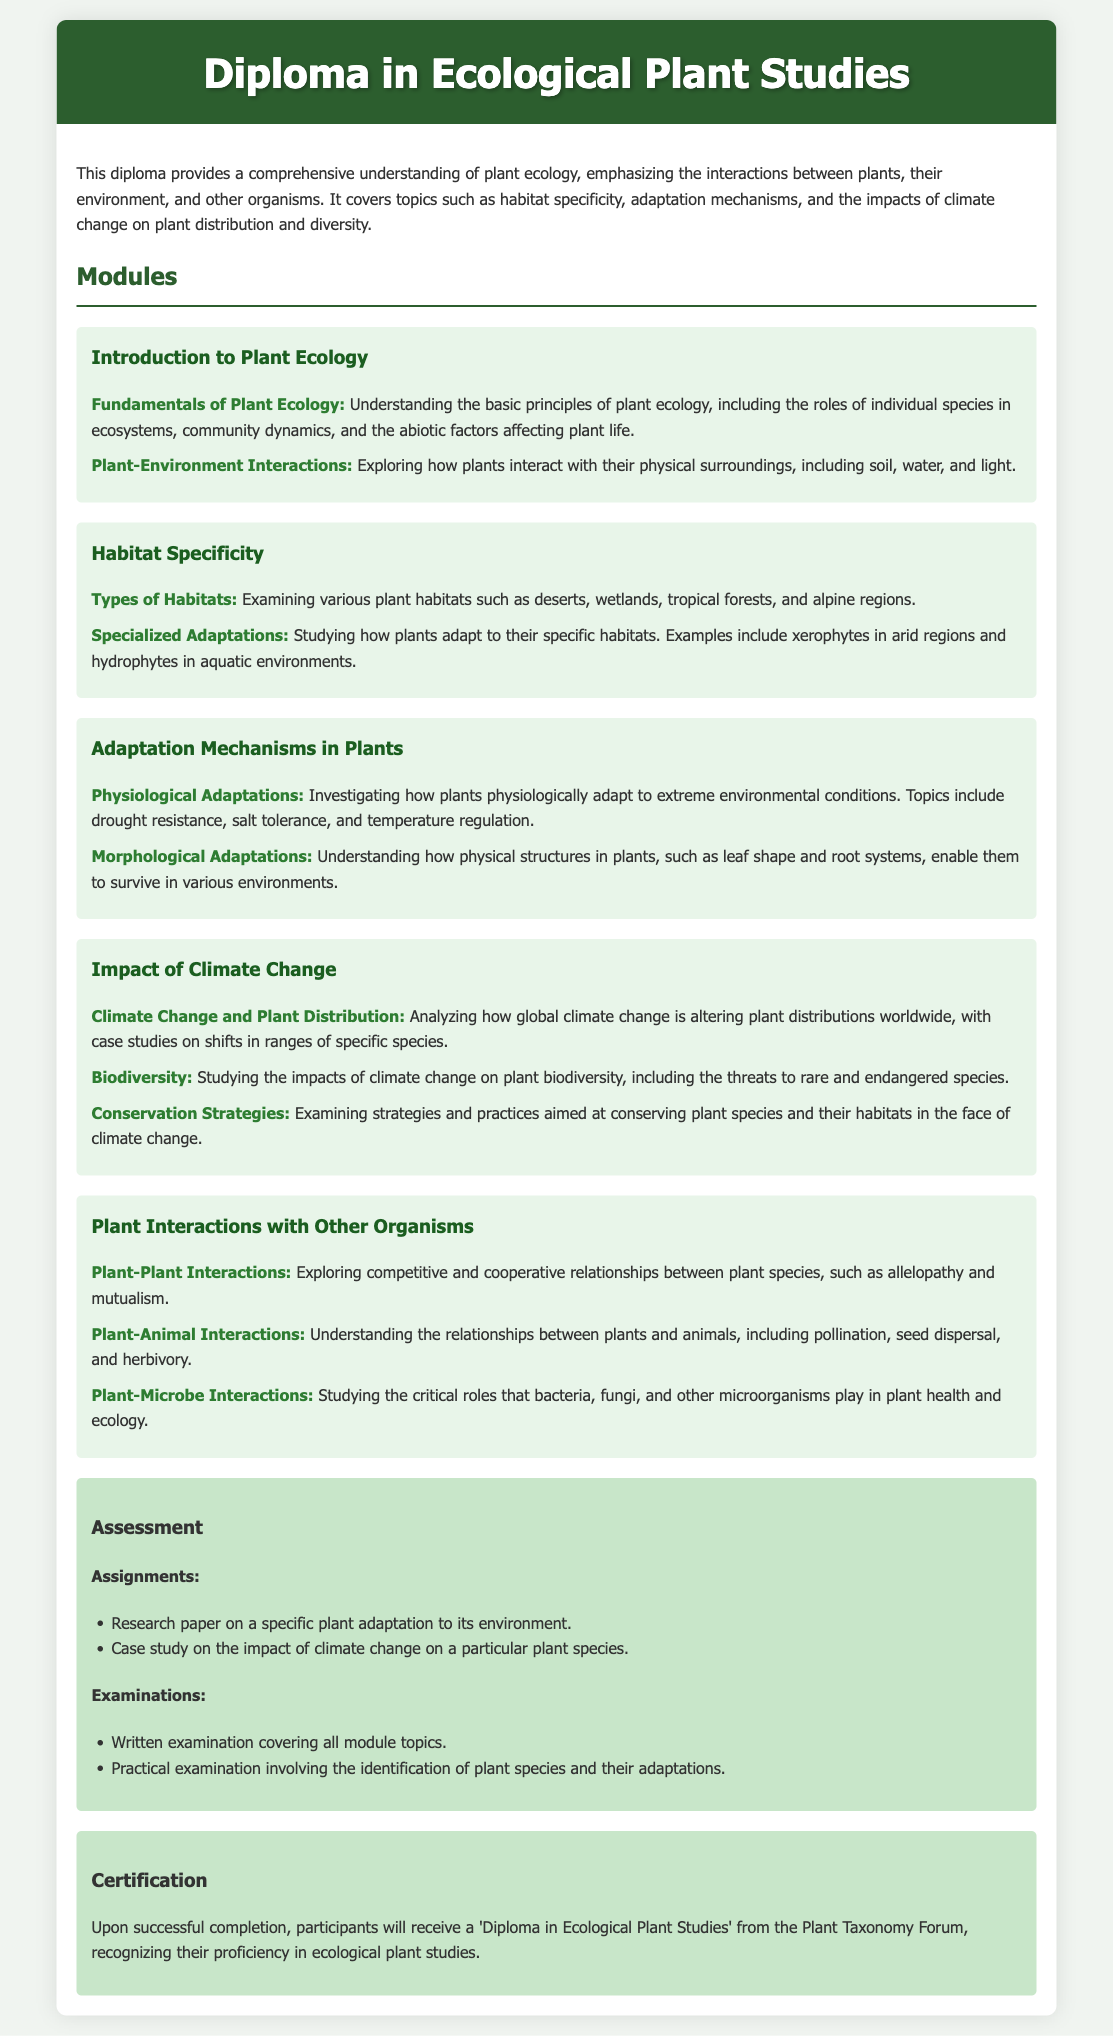What is the title of the diploma? The title of the diploma is the main heading presented at the top of the document.
Answer: Diploma in Ecological Plant Studies How many modules are there in the diploma? The number of modules is determined by counting the sections titled as modules within the document.
Answer: Five What is the focus of the "Impact of Climate Change" module? This focus is described under the module name, which outlines the main areas covered.
Answer: Plant distribution and biodiversity Which adaptation mechanism is related to leaf shape? This mechanism is found in the section discussing how physical structures in plants contribute to their survival.
Answer: Morphological Adaptations What type of assessment involves identifying plant species? This is described as a practical aspect of the assessment process mentioned in the assessment section.
Answer: Practical examination Name one of the topics covered in the "Introduction to Plant Ecology" module. The topics are explicitly listed in the sections under the module heading, providing specific themes.
Answer: Plant-Environment Interactions Who certifies the diploma upon successful completion? The organization or entity responsible for granting the diploma is mentioned in the certification section.
Answer: Plant Taxonomy Forum What is the content of the research paper assignment? The nature of the assignment is found within the assessment section where assignments are listed.
Answer: Specific plant adaptation to its environment 